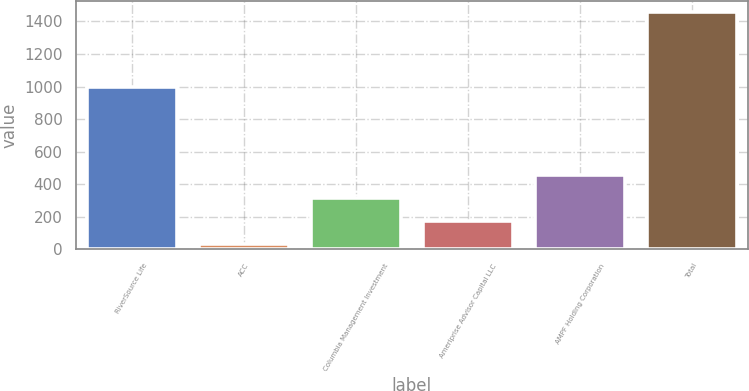Convert chart. <chart><loc_0><loc_0><loc_500><loc_500><bar_chart><fcel>RiverSource Life<fcel>ACC<fcel>Columbia Management Investment<fcel>Ameriprise Advisor Capital LLC<fcel>AMPF Holding Corporation<fcel>Total<nl><fcel>1000<fcel>33<fcel>317.4<fcel>175.2<fcel>459.6<fcel>1455<nl></chart> 